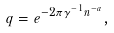<formula> <loc_0><loc_0><loc_500><loc_500>q = e ^ { - 2 \pi \gamma ^ { - 1 } n ^ { - a } } ,</formula> 